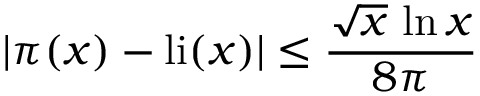<formula> <loc_0><loc_0><loc_500><loc_500>| \pi ( x ) - { l i } ( x ) | \leq { \frac { { \sqrt { x } } \, \ln x } { 8 \pi } }</formula> 